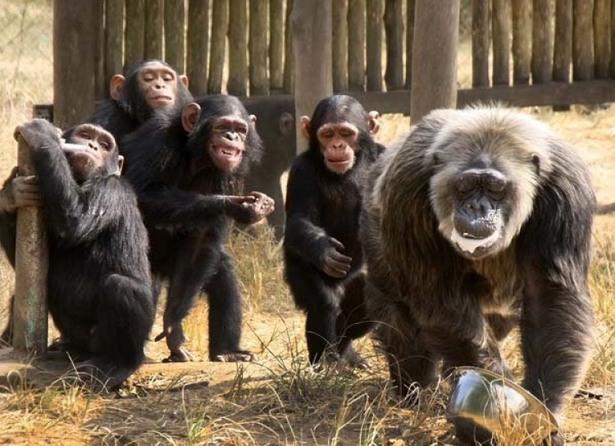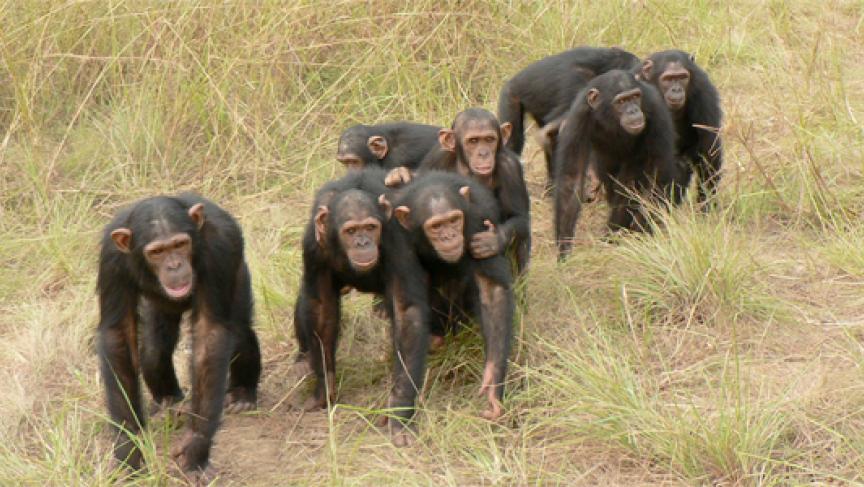The first image is the image on the left, the second image is the image on the right. Evaluate the accuracy of this statement regarding the images: "A baby ape is touching an adult ape's hand". Is it true? Answer yes or no. No. The first image is the image on the left, the second image is the image on the right. Assess this claim about the two images: "An image features one trio of interacting chimps facing forward.". Correct or not? Answer yes or no. No. 